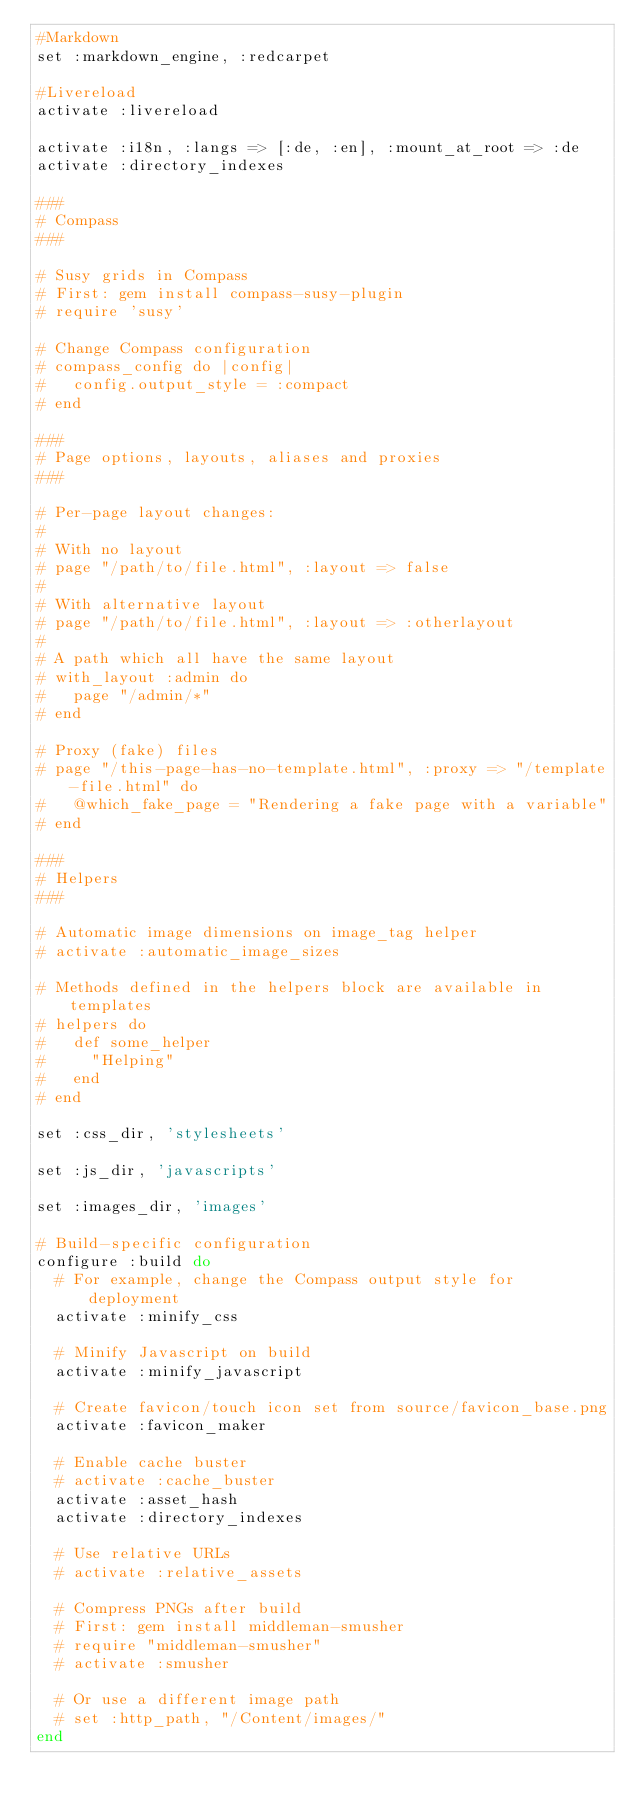<code> <loc_0><loc_0><loc_500><loc_500><_Ruby_>#Markdown
set :markdown_engine, :redcarpet

#Livereload
activate :livereload

activate :i18n, :langs => [:de, :en], :mount_at_root => :de
activate :directory_indexes

### 
# Compass
###

# Susy grids in Compass
# First: gem install compass-susy-plugin
# require 'susy'

# Change Compass configuration
# compass_config do |config|
#   config.output_style = :compact
# end

###
# Page options, layouts, aliases and proxies
###

# Per-page layout changes:
# 
# With no layout
# page "/path/to/file.html", :layout => false
# 
# With alternative layout
# page "/path/to/file.html", :layout => :otherlayout
# 
# A path which all have the same layout
# with_layout :admin do
#   page "/admin/*"
# end

# Proxy (fake) files
# page "/this-page-has-no-template.html", :proxy => "/template-file.html" do
#   @which_fake_page = "Rendering a fake page with a variable"
# end

###
# Helpers
###

# Automatic image dimensions on image_tag helper
# activate :automatic_image_sizes

# Methods defined in the helpers block are available in templates
# helpers do
#   def some_helper
#     "Helping"
#   end
# end

set :css_dir, 'stylesheets'

set :js_dir, 'javascripts'

set :images_dir, 'images'

# Build-specific configuration
configure :build do
  # For example, change the Compass output style for deployment
  activate :minify_css
  
  # Minify Javascript on build
  activate :minify_javascript
  
  # Create favicon/touch icon set from source/favicon_base.png
  activate :favicon_maker
  
  # Enable cache buster
  # activate :cache_buster
  activate :asset_hash
  activate :directory_indexes
  
  # Use relative URLs
  # activate :relative_assets
  
  # Compress PNGs after build
  # First: gem install middleman-smusher
  # require "middleman-smusher"
  # activate :smusher
  
  # Or use a different image path
  # set :http_path, "/Content/images/"
end
</code> 